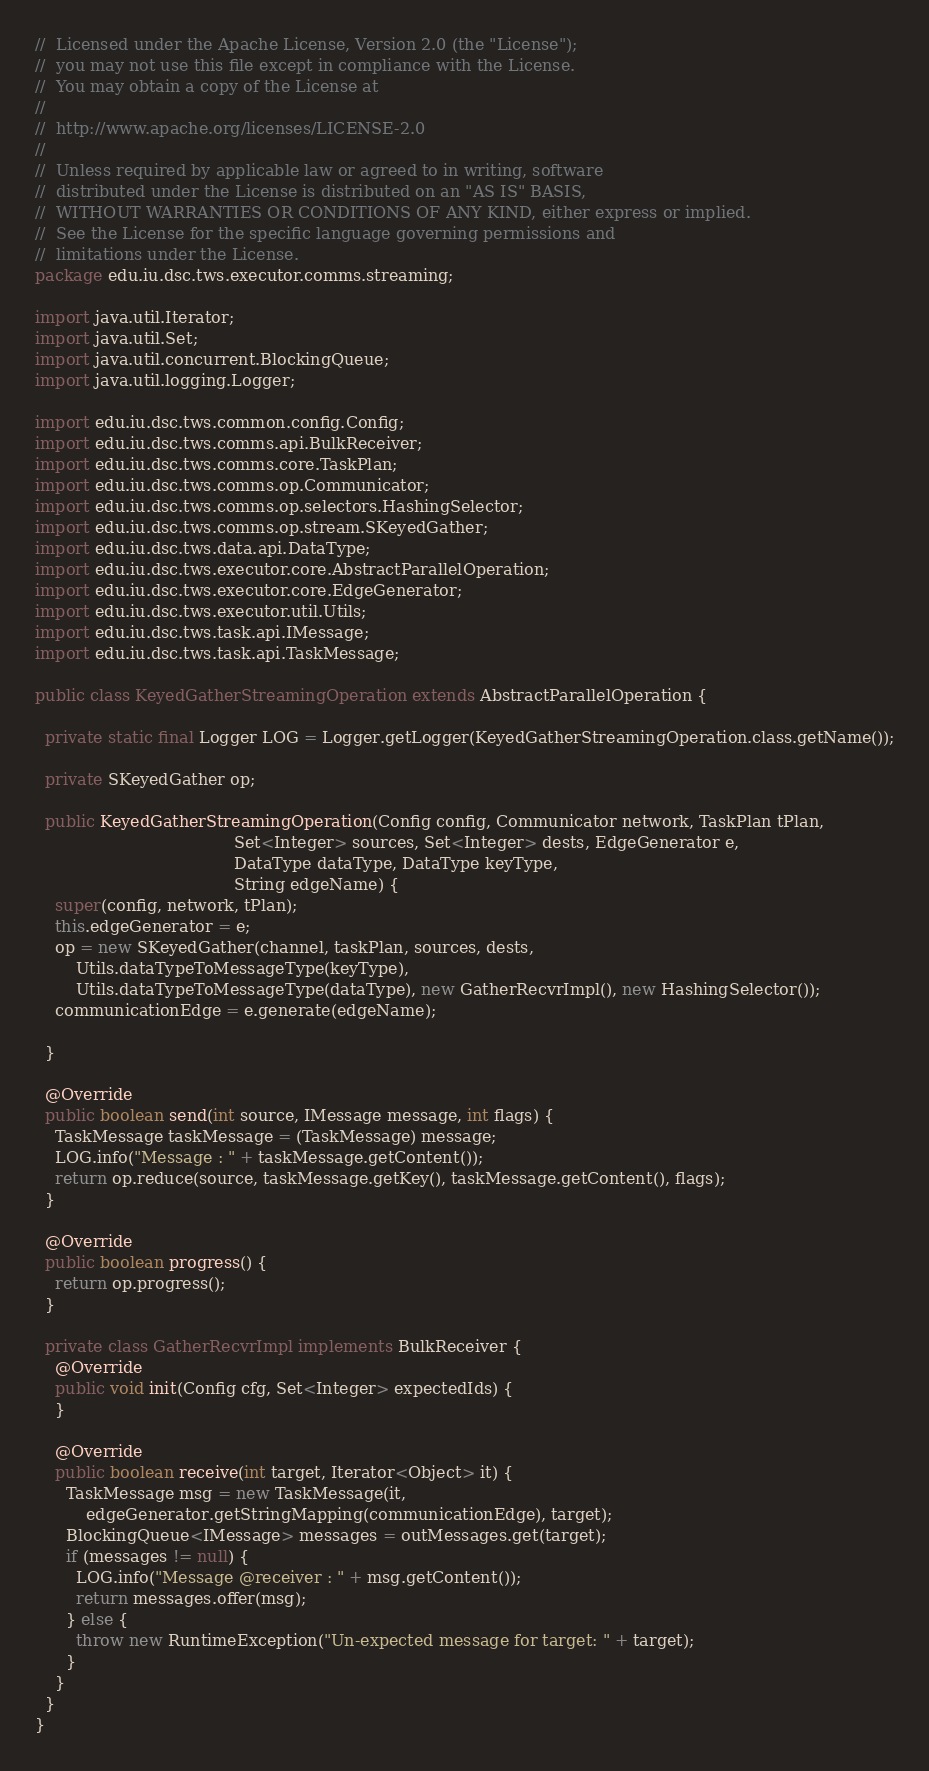<code> <loc_0><loc_0><loc_500><loc_500><_Java_>//  Licensed under the Apache License, Version 2.0 (the "License");
//  you may not use this file except in compliance with the License.
//  You may obtain a copy of the License at
//
//  http://www.apache.org/licenses/LICENSE-2.0
//
//  Unless required by applicable law or agreed to in writing, software
//  distributed under the License is distributed on an "AS IS" BASIS,
//  WITHOUT WARRANTIES OR CONDITIONS OF ANY KIND, either express or implied.
//  See the License for the specific language governing permissions and
//  limitations under the License.
package edu.iu.dsc.tws.executor.comms.streaming;

import java.util.Iterator;
import java.util.Set;
import java.util.concurrent.BlockingQueue;
import java.util.logging.Logger;

import edu.iu.dsc.tws.common.config.Config;
import edu.iu.dsc.tws.comms.api.BulkReceiver;
import edu.iu.dsc.tws.comms.core.TaskPlan;
import edu.iu.dsc.tws.comms.op.Communicator;
import edu.iu.dsc.tws.comms.op.selectors.HashingSelector;
import edu.iu.dsc.tws.comms.op.stream.SKeyedGather;
import edu.iu.dsc.tws.data.api.DataType;
import edu.iu.dsc.tws.executor.core.AbstractParallelOperation;
import edu.iu.dsc.tws.executor.core.EdgeGenerator;
import edu.iu.dsc.tws.executor.util.Utils;
import edu.iu.dsc.tws.task.api.IMessage;
import edu.iu.dsc.tws.task.api.TaskMessage;

public class KeyedGatherStreamingOperation extends AbstractParallelOperation {

  private static final Logger LOG = Logger.getLogger(KeyedGatherStreamingOperation.class.getName());

  private SKeyedGather op;

  public KeyedGatherStreamingOperation(Config config, Communicator network, TaskPlan tPlan,
                                       Set<Integer> sources, Set<Integer> dests, EdgeGenerator e,
                                       DataType dataType, DataType keyType,
                                       String edgeName) {
    super(config, network, tPlan);
    this.edgeGenerator = e;
    op = new SKeyedGather(channel, taskPlan, sources, dests,
        Utils.dataTypeToMessageType(keyType),
        Utils.dataTypeToMessageType(dataType), new GatherRecvrImpl(), new HashingSelector());
    communicationEdge = e.generate(edgeName);

  }

  @Override
  public boolean send(int source, IMessage message, int flags) {
    TaskMessage taskMessage = (TaskMessage) message;
    LOG.info("Message : " + taskMessage.getContent());
    return op.reduce(source, taskMessage.getKey(), taskMessage.getContent(), flags);
  }

  @Override
  public boolean progress() {
    return op.progress();
  }

  private class GatherRecvrImpl implements BulkReceiver {
    @Override
    public void init(Config cfg, Set<Integer> expectedIds) {
    }

    @Override
    public boolean receive(int target, Iterator<Object> it) {
      TaskMessage msg = new TaskMessage(it,
          edgeGenerator.getStringMapping(communicationEdge), target);
      BlockingQueue<IMessage> messages = outMessages.get(target);
      if (messages != null) {
        LOG.info("Message @receiver : " + msg.getContent());
        return messages.offer(msg);
      } else {
        throw new RuntimeException("Un-expected message for target: " + target);
      }
    }
  }
}
</code> 